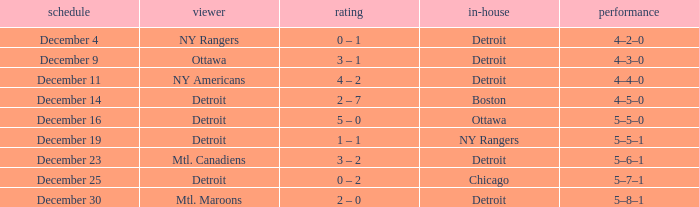What score has mtl. maroons as the visitor? 2 – 0. 